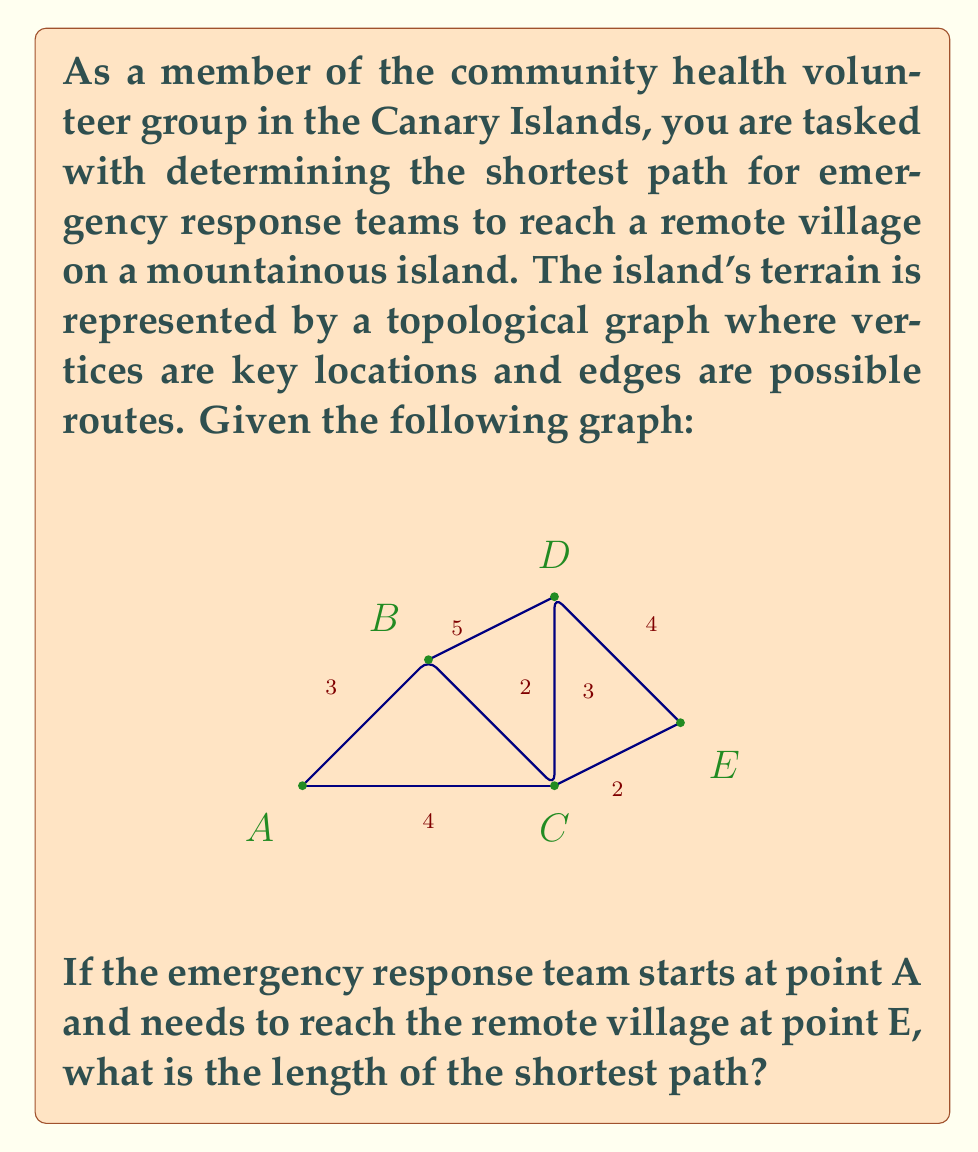Show me your answer to this math problem. To solve this problem, we'll use Dijkstra's algorithm, which is an efficient method for finding the shortest path in a weighted graph.

Step 1: Initialize distances
Set distance to A as 0, and all other distances as infinity.
A: 0, B: ∞, C: ∞, D: ∞, E: ∞

Step 2: Visit vertex A
Update distances:
A to B: 3
A to C: 4
A: 0, B: 3, C: 4, D: ∞, E: ∞

Step 3: Visit vertex B (closest unvisited vertex)
Update distances:
B to C: min(4, 3+2) = 4
B to D: 3+5 = 8
A: 0, B: 3, C: 4, D: 8, E: ∞

Step 4: Visit vertex C
Update distances:
C to D: min(8, 4+3) = 7
C to E: 4+2 = 6
A: 0, B: 3, C: 4, D: 7, E: 6

Step 5: Visit vertex E (closest unvisited vertex)
No updates needed as E is our destination.

The shortest path from A to E has a length of 6.

The actual path is A → C → E.
Answer: The length of the shortest path from A to E is 6. 